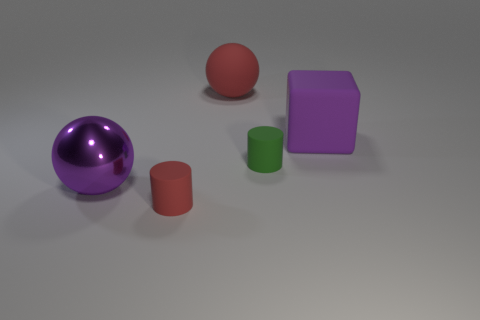If these objects were part of a game, what rules could apply? If we imagine these objects as part of a game, we could create a matching or sorting game where players must group the objects by color, material, or shape. For instance, players might be tasked with arranging the objects from smallest to largest or separating the metallic from the non-metallic items. Alternatively, they could be used in a memory game where each object is paired with a matching one, and players must find the pairs based on physical properties. 